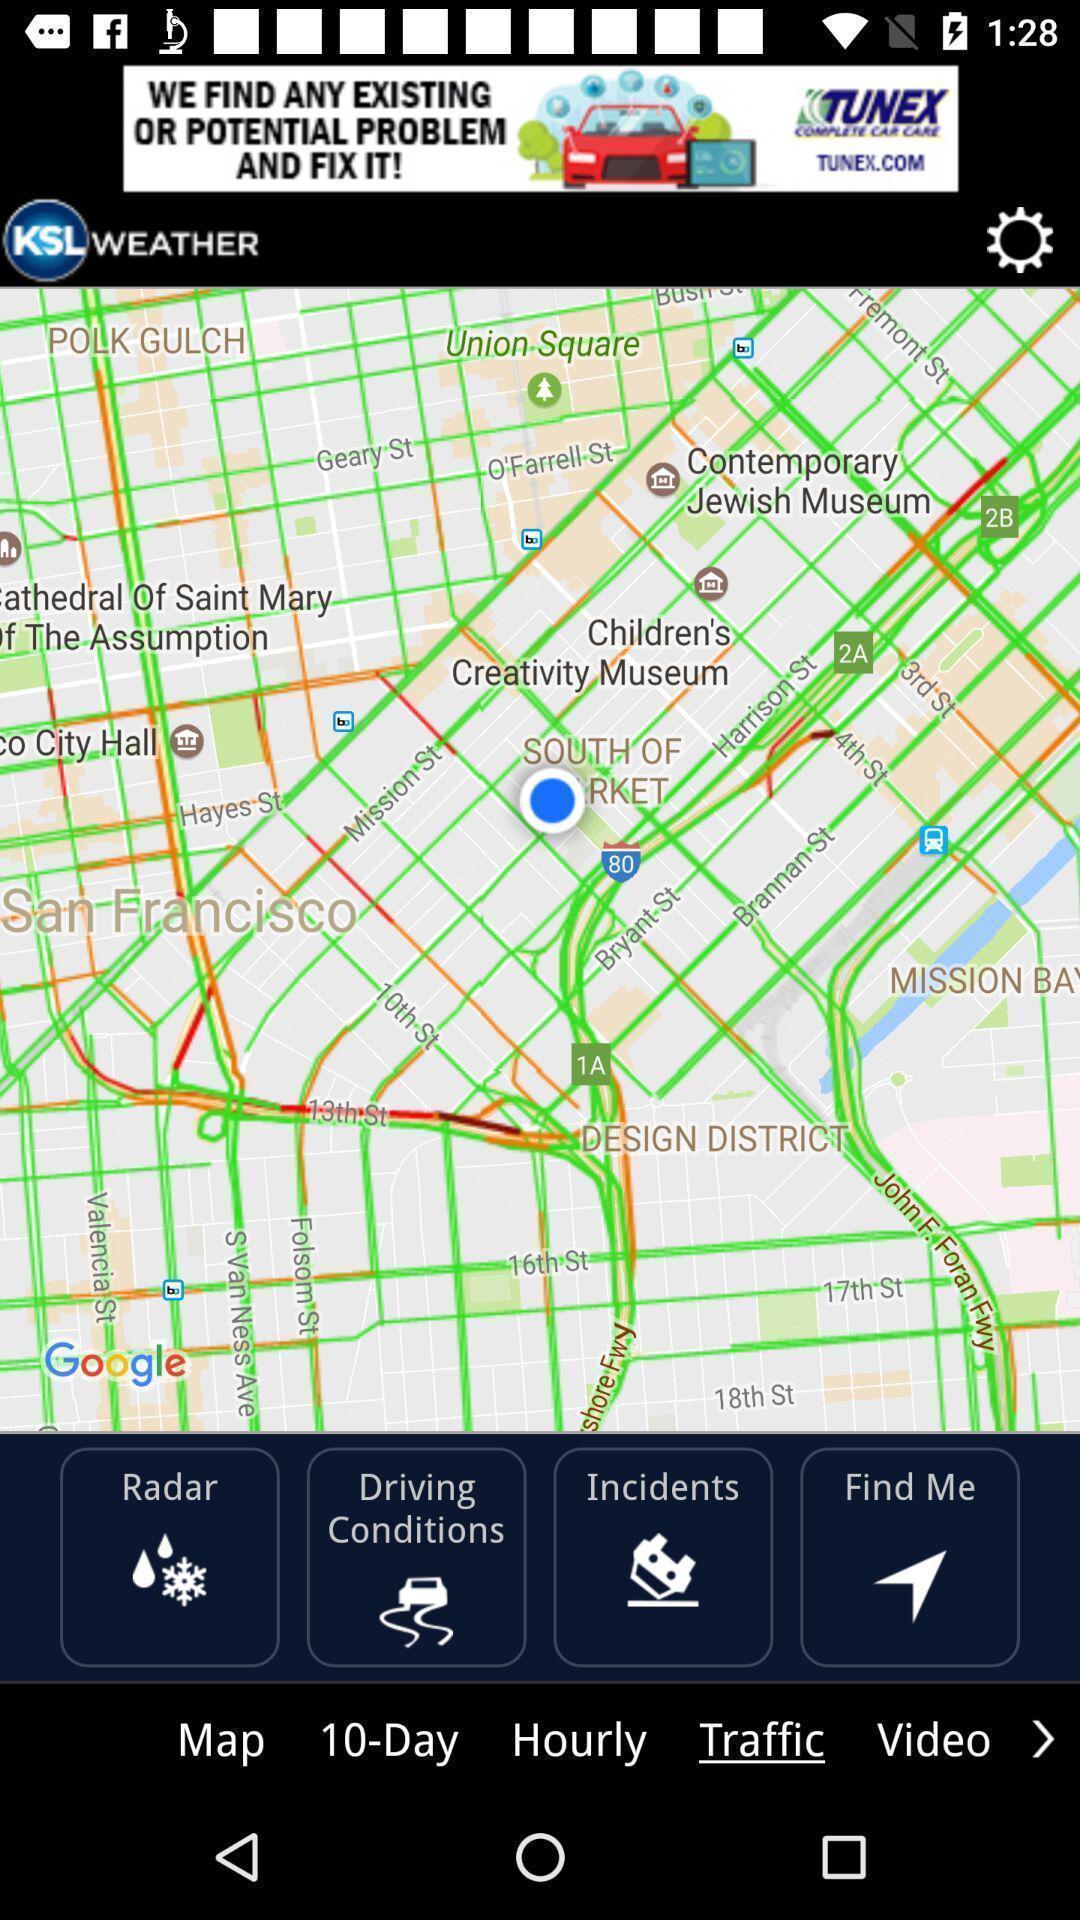What details can you identify in this image? Page showing information about weather. 